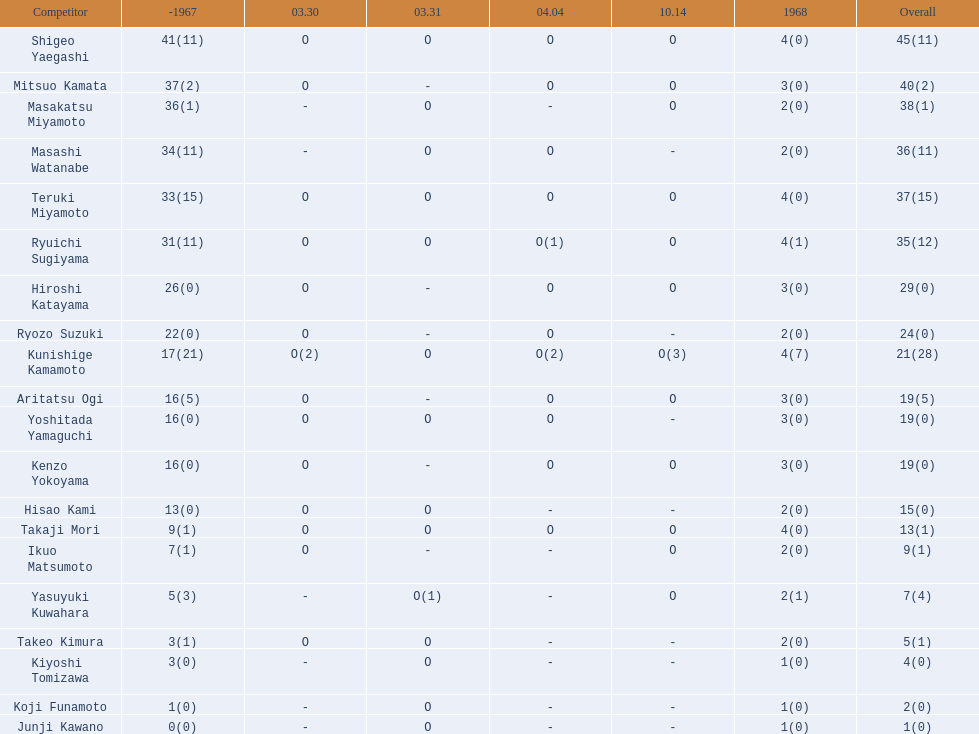Who are all of the players? Shigeo Yaegashi, Mitsuo Kamata, Masakatsu Miyamoto, Masashi Watanabe, Teruki Miyamoto, Ryuichi Sugiyama, Hiroshi Katayama, Ryozo Suzuki, Kunishige Kamamoto, Aritatsu Ogi, Yoshitada Yamaguchi, Kenzo Yokoyama, Hisao Kami, Takaji Mori, Ikuo Matsumoto, Yasuyuki Kuwahara, Takeo Kimura, Kiyoshi Tomizawa, Koji Funamoto, Junji Kawano. How many points did they receive? 45(11), 40(2), 38(1), 36(11), 37(15), 35(12), 29(0), 24(0), 21(28), 19(5), 19(0), 19(0), 15(0), 13(1), 9(1), 7(4), 5(1), 4(0), 2(0), 1(0). What about just takaji mori and junji kawano? 13(1), 1(0). Of the two, who had more points? Takaji Mori. 